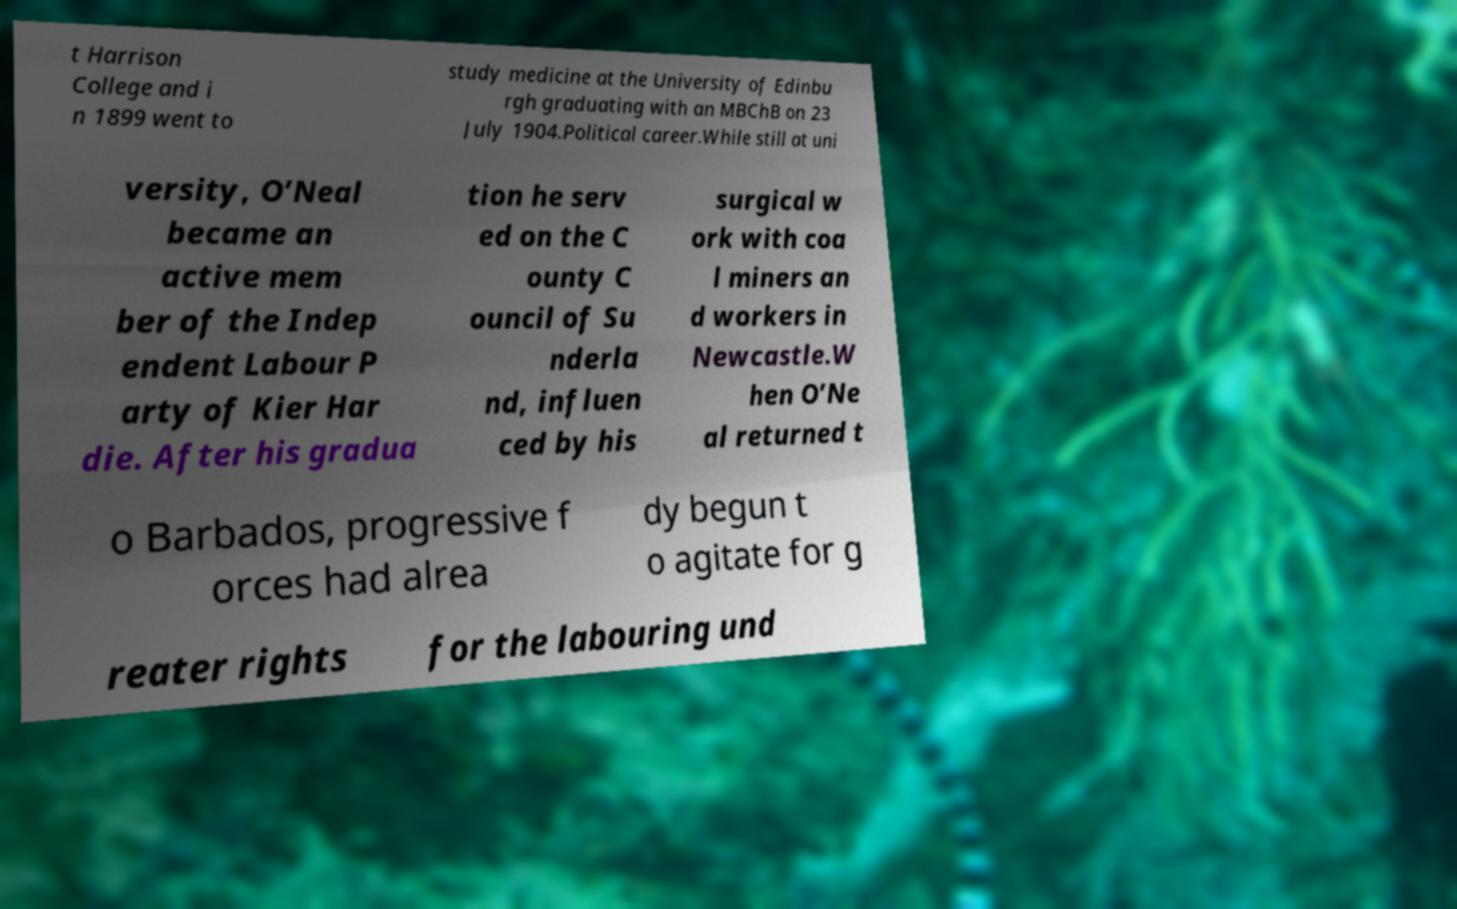I need the written content from this picture converted into text. Can you do that? t Harrison College and i n 1899 went to study medicine at the University of Edinbu rgh graduating with an MBChB on 23 July 1904.Political career.While still at uni versity, O’Neal became an active mem ber of the Indep endent Labour P arty of Kier Har die. After his gradua tion he serv ed on the C ounty C ouncil of Su nderla nd, influen ced by his surgical w ork with coa l miners an d workers in Newcastle.W hen O’Ne al returned t o Barbados, progressive f orces had alrea dy begun t o agitate for g reater rights for the labouring und 